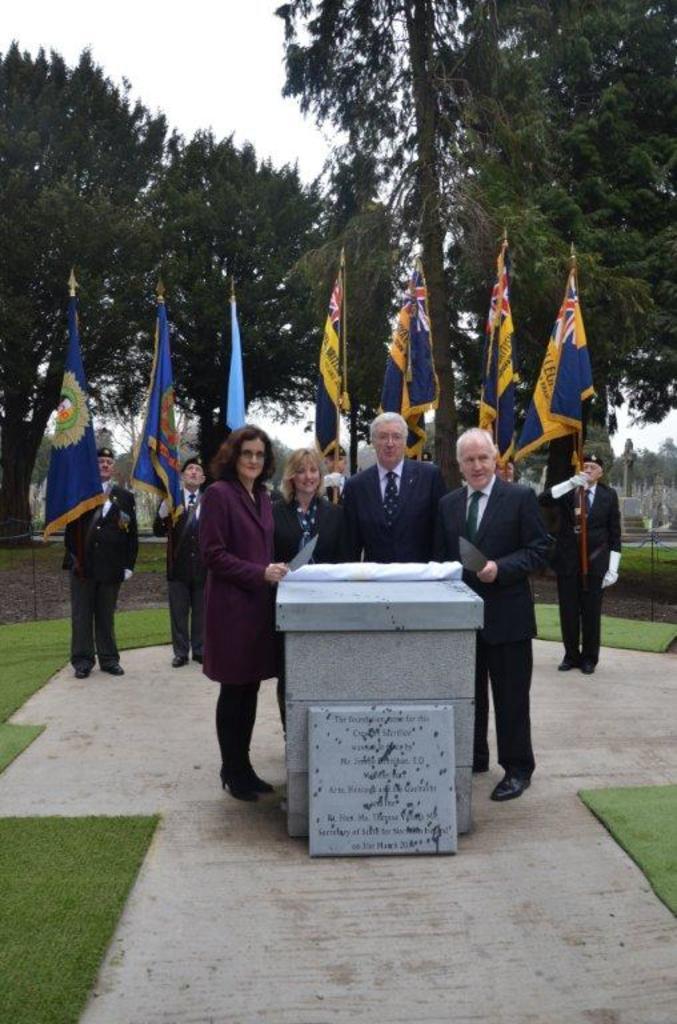How would you summarize this image in a sentence or two? In this image I can see memorial stones, grass, flags, people, trees and sky. 